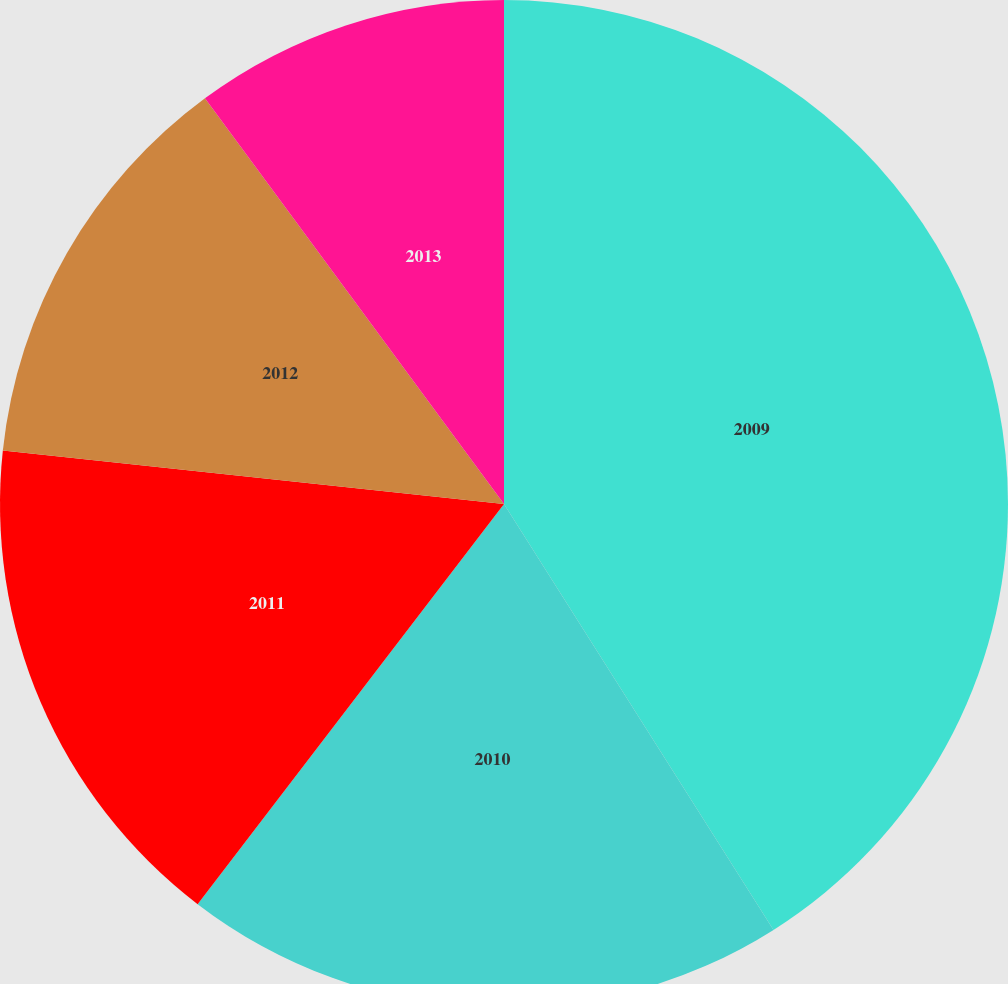<chart> <loc_0><loc_0><loc_500><loc_500><pie_chart><fcel>2009<fcel>2010<fcel>2011<fcel>2012<fcel>2013<nl><fcel>41.02%<fcel>19.38%<fcel>16.29%<fcel>13.2%<fcel>10.11%<nl></chart> 